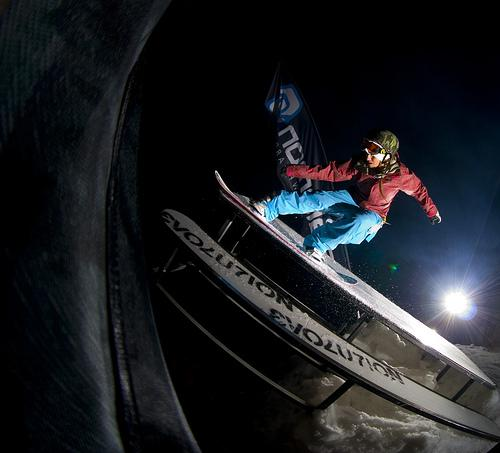Question: what sport is taking place?
Choices:
A. Football.
B. Cricket.
C. Snowboarding.
D. Basketball.
Answer with the letter. Answer: C Question: how many people are shown snowboarding?
Choices:
A. Zero.
B. Two.
C. One.
D. Three.
Answer with the letter. Answer: C Question: why is the ground white?
Choices:
A. Salt flats.
B. White sand.
C. Painted grass.
D. Snow.
Answer with the letter. Answer: D Question: what is written on the park bench?
Choices:
A. Wet paint.
B. Evolution.
C. No loitering.
D. Greta for Mayor.
Answer with the letter. Answer: B Question: how many lights are there?
Choices:
A. One.
B. Zero.
C. Two.
D. Three.
Answer with the letter. Answer: A Question: when was the photo shot?
Choices:
A. Valentine's Day.
B. Their anniversary.
C. My birthday.
D. Night.
Answer with the letter. Answer: D 